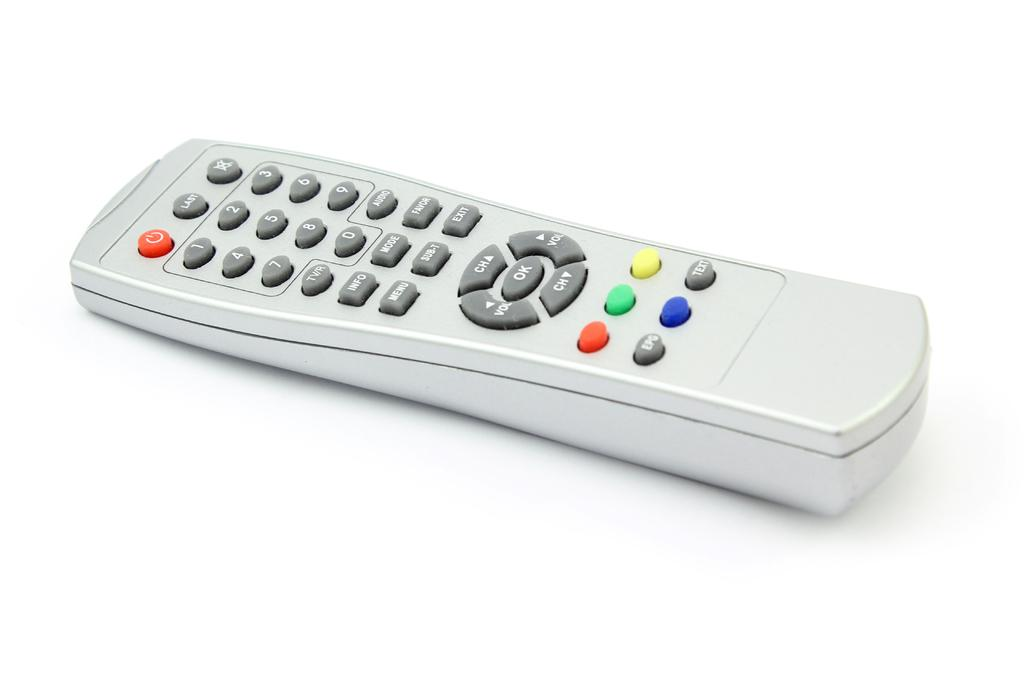<image>
Write a terse but informative summary of the picture. a remote with the word ok on it 